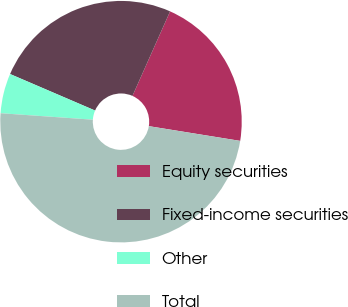<chart> <loc_0><loc_0><loc_500><loc_500><pie_chart><fcel>Equity securities<fcel>Fixed-income securities<fcel>Other<fcel>Total<nl><fcel>20.88%<fcel>25.21%<fcel>5.34%<fcel>48.57%<nl></chart> 